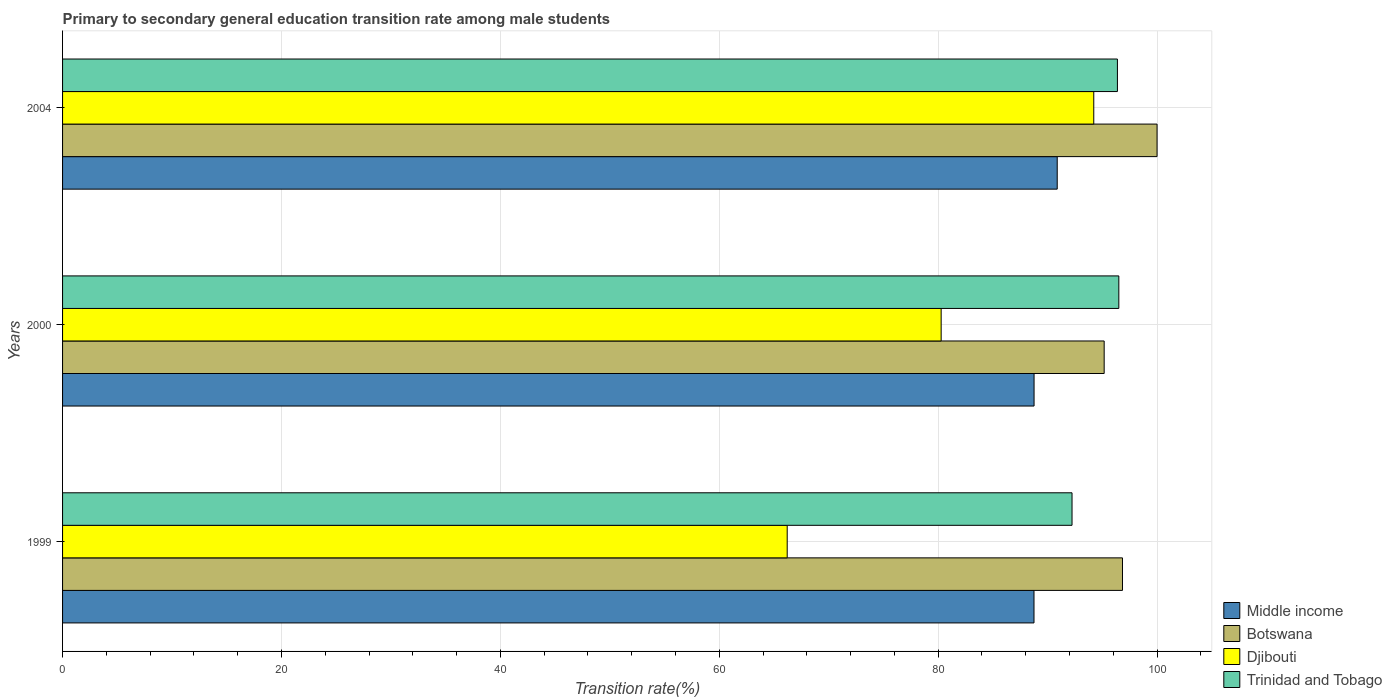How many different coloured bars are there?
Offer a very short reply. 4. How many groups of bars are there?
Provide a short and direct response. 3. Are the number of bars per tick equal to the number of legend labels?
Offer a very short reply. Yes. Are the number of bars on each tick of the Y-axis equal?
Your response must be concise. Yes. How many bars are there on the 2nd tick from the top?
Offer a very short reply. 4. What is the transition rate in Djibouti in 1999?
Offer a terse response. 66.21. Across all years, what is the maximum transition rate in Trinidad and Tobago?
Provide a succinct answer. 96.51. Across all years, what is the minimum transition rate in Middle income?
Provide a short and direct response. 88.76. In which year was the transition rate in Djibouti maximum?
Offer a terse response. 2004. In which year was the transition rate in Botswana minimum?
Give a very brief answer. 2000. What is the total transition rate in Middle income in the graph?
Ensure brevity in your answer.  268.4. What is the difference between the transition rate in Djibouti in 1999 and that in 2000?
Make the answer very short. -14.07. What is the difference between the transition rate in Middle income in 2004 and the transition rate in Botswana in 2000?
Your answer should be very brief. -4.29. What is the average transition rate in Middle income per year?
Your answer should be very brief. 89.47. In the year 1999, what is the difference between the transition rate in Djibouti and transition rate in Botswana?
Provide a short and direct response. -30.63. What is the ratio of the transition rate in Middle income in 1999 to that in 2004?
Ensure brevity in your answer.  0.98. Is the difference between the transition rate in Djibouti in 1999 and 2004 greater than the difference between the transition rate in Botswana in 1999 and 2004?
Your response must be concise. No. What is the difference between the highest and the second highest transition rate in Middle income?
Offer a very short reply. 2.12. What is the difference between the highest and the lowest transition rate in Djibouti?
Provide a succinct answer. 28.01. In how many years, is the transition rate in Trinidad and Tobago greater than the average transition rate in Trinidad and Tobago taken over all years?
Give a very brief answer. 2. Is the sum of the transition rate in Trinidad and Tobago in 1999 and 2004 greater than the maximum transition rate in Djibouti across all years?
Offer a very short reply. Yes. Is it the case that in every year, the sum of the transition rate in Djibouti and transition rate in Trinidad and Tobago is greater than the sum of transition rate in Botswana and transition rate in Middle income?
Offer a very short reply. No. What does the 4th bar from the bottom in 2000 represents?
Provide a short and direct response. Trinidad and Tobago. Is it the case that in every year, the sum of the transition rate in Middle income and transition rate in Djibouti is greater than the transition rate in Botswana?
Your answer should be very brief. Yes. How many bars are there?
Your answer should be compact. 12. Are all the bars in the graph horizontal?
Your answer should be very brief. Yes. How many years are there in the graph?
Offer a terse response. 3. What is the difference between two consecutive major ticks on the X-axis?
Offer a terse response. 20. Does the graph contain any zero values?
Make the answer very short. No. Does the graph contain grids?
Provide a succinct answer. Yes. How are the legend labels stacked?
Offer a terse response. Vertical. What is the title of the graph?
Your response must be concise. Primary to secondary general education transition rate among male students. Does "Timor-Leste" appear as one of the legend labels in the graph?
Give a very brief answer. No. What is the label or title of the X-axis?
Keep it short and to the point. Transition rate(%). What is the label or title of the Y-axis?
Provide a short and direct response. Years. What is the Transition rate(%) in Middle income in 1999?
Your answer should be very brief. 88.76. What is the Transition rate(%) of Botswana in 1999?
Provide a succinct answer. 96.84. What is the Transition rate(%) in Djibouti in 1999?
Your answer should be very brief. 66.21. What is the Transition rate(%) of Trinidad and Tobago in 1999?
Offer a terse response. 92.23. What is the Transition rate(%) of Middle income in 2000?
Give a very brief answer. 88.76. What is the Transition rate(%) of Botswana in 2000?
Give a very brief answer. 95.17. What is the Transition rate(%) of Djibouti in 2000?
Make the answer very short. 80.27. What is the Transition rate(%) of Trinidad and Tobago in 2000?
Your response must be concise. 96.51. What is the Transition rate(%) of Middle income in 2004?
Offer a terse response. 90.88. What is the Transition rate(%) of Botswana in 2004?
Keep it short and to the point. 100. What is the Transition rate(%) of Djibouti in 2004?
Provide a short and direct response. 94.22. What is the Transition rate(%) of Trinidad and Tobago in 2004?
Keep it short and to the point. 96.38. Across all years, what is the maximum Transition rate(%) in Middle income?
Offer a very short reply. 90.88. Across all years, what is the maximum Transition rate(%) of Djibouti?
Your answer should be compact. 94.22. Across all years, what is the maximum Transition rate(%) in Trinidad and Tobago?
Give a very brief answer. 96.51. Across all years, what is the minimum Transition rate(%) in Middle income?
Your response must be concise. 88.76. Across all years, what is the minimum Transition rate(%) of Botswana?
Your answer should be compact. 95.17. Across all years, what is the minimum Transition rate(%) in Djibouti?
Your answer should be very brief. 66.21. Across all years, what is the minimum Transition rate(%) of Trinidad and Tobago?
Give a very brief answer. 92.23. What is the total Transition rate(%) in Middle income in the graph?
Give a very brief answer. 268.4. What is the total Transition rate(%) of Botswana in the graph?
Give a very brief answer. 292.01. What is the total Transition rate(%) in Djibouti in the graph?
Offer a terse response. 240.7. What is the total Transition rate(%) of Trinidad and Tobago in the graph?
Make the answer very short. 285.12. What is the difference between the Transition rate(%) in Middle income in 1999 and that in 2000?
Offer a terse response. -0.01. What is the difference between the Transition rate(%) in Botswana in 1999 and that in 2000?
Make the answer very short. 1.67. What is the difference between the Transition rate(%) in Djibouti in 1999 and that in 2000?
Provide a short and direct response. -14.07. What is the difference between the Transition rate(%) in Trinidad and Tobago in 1999 and that in 2000?
Ensure brevity in your answer.  -4.28. What is the difference between the Transition rate(%) in Middle income in 1999 and that in 2004?
Keep it short and to the point. -2.12. What is the difference between the Transition rate(%) in Botswana in 1999 and that in 2004?
Make the answer very short. -3.16. What is the difference between the Transition rate(%) in Djibouti in 1999 and that in 2004?
Your answer should be very brief. -28.01. What is the difference between the Transition rate(%) in Trinidad and Tobago in 1999 and that in 2004?
Your answer should be compact. -4.15. What is the difference between the Transition rate(%) of Middle income in 2000 and that in 2004?
Provide a succinct answer. -2.12. What is the difference between the Transition rate(%) of Botswana in 2000 and that in 2004?
Keep it short and to the point. -4.83. What is the difference between the Transition rate(%) of Djibouti in 2000 and that in 2004?
Make the answer very short. -13.94. What is the difference between the Transition rate(%) of Trinidad and Tobago in 2000 and that in 2004?
Your answer should be compact. 0.13. What is the difference between the Transition rate(%) of Middle income in 1999 and the Transition rate(%) of Botswana in 2000?
Offer a very short reply. -6.41. What is the difference between the Transition rate(%) of Middle income in 1999 and the Transition rate(%) of Djibouti in 2000?
Provide a short and direct response. 8.48. What is the difference between the Transition rate(%) of Middle income in 1999 and the Transition rate(%) of Trinidad and Tobago in 2000?
Provide a succinct answer. -7.75. What is the difference between the Transition rate(%) in Botswana in 1999 and the Transition rate(%) in Djibouti in 2000?
Make the answer very short. 16.57. What is the difference between the Transition rate(%) of Botswana in 1999 and the Transition rate(%) of Trinidad and Tobago in 2000?
Your answer should be very brief. 0.33. What is the difference between the Transition rate(%) in Djibouti in 1999 and the Transition rate(%) in Trinidad and Tobago in 2000?
Ensure brevity in your answer.  -30.3. What is the difference between the Transition rate(%) in Middle income in 1999 and the Transition rate(%) in Botswana in 2004?
Your answer should be compact. -11.24. What is the difference between the Transition rate(%) in Middle income in 1999 and the Transition rate(%) in Djibouti in 2004?
Your answer should be very brief. -5.46. What is the difference between the Transition rate(%) of Middle income in 1999 and the Transition rate(%) of Trinidad and Tobago in 2004?
Provide a short and direct response. -7.62. What is the difference between the Transition rate(%) of Botswana in 1999 and the Transition rate(%) of Djibouti in 2004?
Offer a terse response. 2.62. What is the difference between the Transition rate(%) in Botswana in 1999 and the Transition rate(%) in Trinidad and Tobago in 2004?
Your answer should be compact. 0.46. What is the difference between the Transition rate(%) of Djibouti in 1999 and the Transition rate(%) of Trinidad and Tobago in 2004?
Your response must be concise. -30.17. What is the difference between the Transition rate(%) of Middle income in 2000 and the Transition rate(%) of Botswana in 2004?
Make the answer very short. -11.24. What is the difference between the Transition rate(%) of Middle income in 2000 and the Transition rate(%) of Djibouti in 2004?
Provide a short and direct response. -5.45. What is the difference between the Transition rate(%) of Middle income in 2000 and the Transition rate(%) of Trinidad and Tobago in 2004?
Your response must be concise. -7.62. What is the difference between the Transition rate(%) in Botswana in 2000 and the Transition rate(%) in Djibouti in 2004?
Give a very brief answer. 0.95. What is the difference between the Transition rate(%) of Botswana in 2000 and the Transition rate(%) of Trinidad and Tobago in 2004?
Give a very brief answer. -1.21. What is the difference between the Transition rate(%) in Djibouti in 2000 and the Transition rate(%) in Trinidad and Tobago in 2004?
Keep it short and to the point. -16.11. What is the average Transition rate(%) in Middle income per year?
Keep it short and to the point. 89.47. What is the average Transition rate(%) in Botswana per year?
Provide a short and direct response. 97.34. What is the average Transition rate(%) of Djibouti per year?
Provide a short and direct response. 80.23. What is the average Transition rate(%) in Trinidad and Tobago per year?
Your answer should be compact. 95.04. In the year 1999, what is the difference between the Transition rate(%) of Middle income and Transition rate(%) of Botswana?
Provide a short and direct response. -8.08. In the year 1999, what is the difference between the Transition rate(%) of Middle income and Transition rate(%) of Djibouti?
Make the answer very short. 22.55. In the year 1999, what is the difference between the Transition rate(%) in Middle income and Transition rate(%) in Trinidad and Tobago?
Your answer should be very brief. -3.47. In the year 1999, what is the difference between the Transition rate(%) of Botswana and Transition rate(%) of Djibouti?
Offer a very short reply. 30.63. In the year 1999, what is the difference between the Transition rate(%) in Botswana and Transition rate(%) in Trinidad and Tobago?
Your answer should be very brief. 4.61. In the year 1999, what is the difference between the Transition rate(%) of Djibouti and Transition rate(%) of Trinidad and Tobago?
Offer a very short reply. -26.02. In the year 2000, what is the difference between the Transition rate(%) in Middle income and Transition rate(%) in Botswana?
Ensure brevity in your answer.  -6.41. In the year 2000, what is the difference between the Transition rate(%) in Middle income and Transition rate(%) in Djibouti?
Provide a short and direct response. 8.49. In the year 2000, what is the difference between the Transition rate(%) in Middle income and Transition rate(%) in Trinidad and Tobago?
Your answer should be compact. -7.74. In the year 2000, what is the difference between the Transition rate(%) in Botswana and Transition rate(%) in Djibouti?
Give a very brief answer. 14.89. In the year 2000, what is the difference between the Transition rate(%) in Botswana and Transition rate(%) in Trinidad and Tobago?
Your response must be concise. -1.34. In the year 2000, what is the difference between the Transition rate(%) of Djibouti and Transition rate(%) of Trinidad and Tobago?
Offer a very short reply. -16.23. In the year 2004, what is the difference between the Transition rate(%) in Middle income and Transition rate(%) in Botswana?
Your answer should be very brief. -9.12. In the year 2004, what is the difference between the Transition rate(%) in Middle income and Transition rate(%) in Djibouti?
Offer a very short reply. -3.34. In the year 2004, what is the difference between the Transition rate(%) in Middle income and Transition rate(%) in Trinidad and Tobago?
Offer a very short reply. -5.5. In the year 2004, what is the difference between the Transition rate(%) in Botswana and Transition rate(%) in Djibouti?
Give a very brief answer. 5.78. In the year 2004, what is the difference between the Transition rate(%) in Botswana and Transition rate(%) in Trinidad and Tobago?
Make the answer very short. 3.62. In the year 2004, what is the difference between the Transition rate(%) of Djibouti and Transition rate(%) of Trinidad and Tobago?
Your answer should be very brief. -2.16. What is the ratio of the Transition rate(%) of Middle income in 1999 to that in 2000?
Offer a terse response. 1. What is the ratio of the Transition rate(%) of Botswana in 1999 to that in 2000?
Offer a terse response. 1.02. What is the ratio of the Transition rate(%) in Djibouti in 1999 to that in 2000?
Provide a short and direct response. 0.82. What is the ratio of the Transition rate(%) of Trinidad and Tobago in 1999 to that in 2000?
Make the answer very short. 0.96. What is the ratio of the Transition rate(%) in Middle income in 1999 to that in 2004?
Your answer should be compact. 0.98. What is the ratio of the Transition rate(%) of Botswana in 1999 to that in 2004?
Your answer should be very brief. 0.97. What is the ratio of the Transition rate(%) of Djibouti in 1999 to that in 2004?
Provide a short and direct response. 0.7. What is the ratio of the Transition rate(%) of Middle income in 2000 to that in 2004?
Give a very brief answer. 0.98. What is the ratio of the Transition rate(%) of Botswana in 2000 to that in 2004?
Make the answer very short. 0.95. What is the ratio of the Transition rate(%) of Djibouti in 2000 to that in 2004?
Give a very brief answer. 0.85. What is the difference between the highest and the second highest Transition rate(%) in Middle income?
Your response must be concise. 2.12. What is the difference between the highest and the second highest Transition rate(%) of Botswana?
Keep it short and to the point. 3.16. What is the difference between the highest and the second highest Transition rate(%) of Djibouti?
Make the answer very short. 13.94. What is the difference between the highest and the second highest Transition rate(%) of Trinidad and Tobago?
Provide a succinct answer. 0.13. What is the difference between the highest and the lowest Transition rate(%) of Middle income?
Provide a succinct answer. 2.12. What is the difference between the highest and the lowest Transition rate(%) in Botswana?
Provide a succinct answer. 4.83. What is the difference between the highest and the lowest Transition rate(%) in Djibouti?
Your response must be concise. 28.01. What is the difference between the highest and the lowest Transition rate(%) in Trinidad and Tobago?
Ensure brevity in your answer.  4.28. 